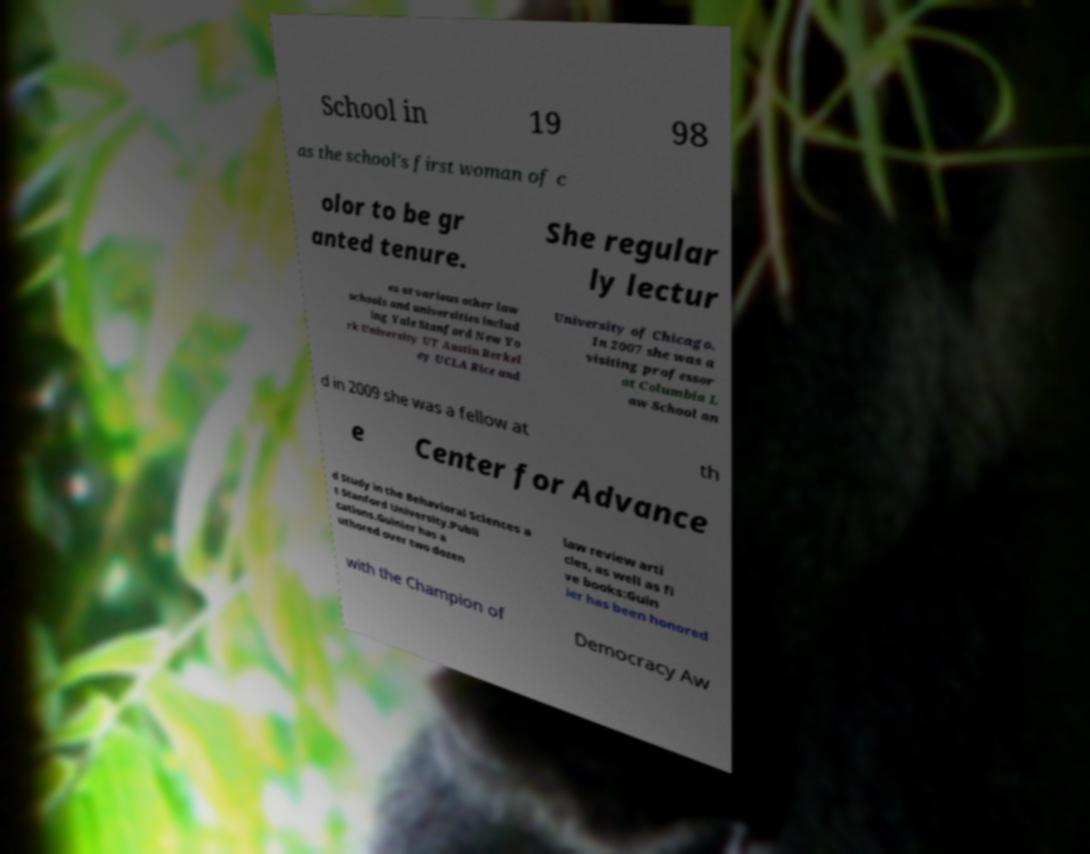I need the written content from this picture converted into text. Can you do that? School in 19 98 as the school's first woman of c olor to be gr anted tenure. She regular ly lectur es at various other law schools and universities includ ing Yale Stanford New Yo rk University UT Austin Berkel ey UCLA Rice and University of Chicago. In 2007 she was a visiting professor at Columbia L aw School an d in 2009 she was a fellow at th e Center for Advance d Study in the Behavioral Sciences a t Stanford University.Publi cations.Guinier has a uthored over two dozen law review arti cles, as well as fi ve books:Guin ier has been honored with the Champion of Democracy Aw 